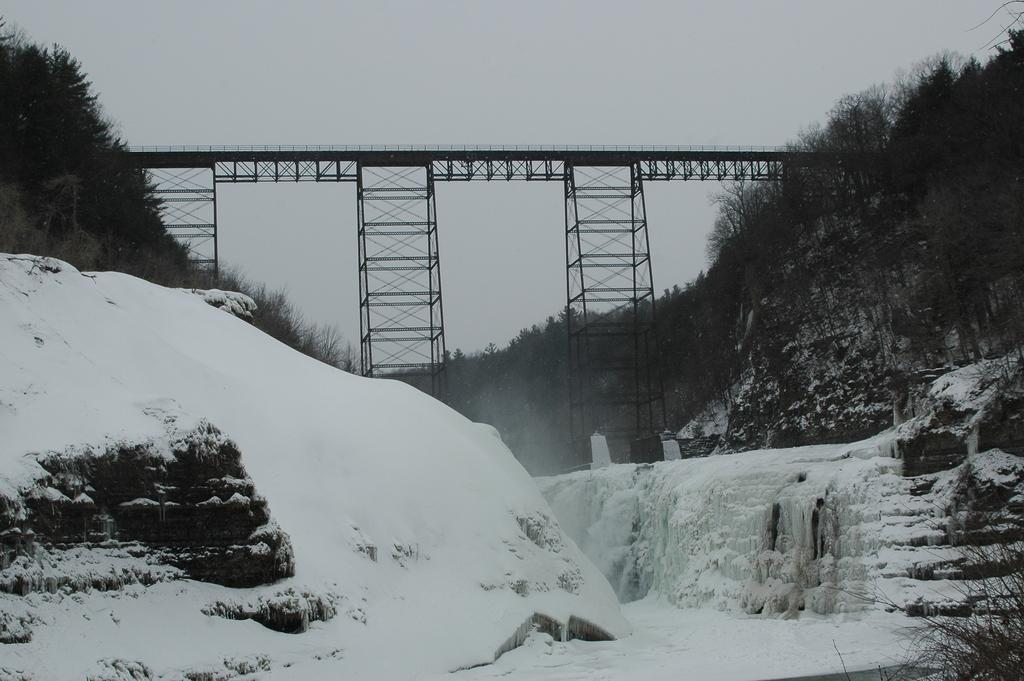What is covering the ground in the image? There is snow on the ground. What type of natural features can be seen in the image? Rocks are visible in the image. What structures can be seen in the background of the image? There is a bridge and poles in the background of the image. What type of vegetation is visible in the background of the image? There are trees in the background of the image. What else can be seen in the background of the image? There are rocks in the background of the image. What part of the natural environment is visible in the background of the image? The sky is visible in the background of the image. What type of juice is being served in the image? There is no juice present in the image; it features snow, rocks, a bridge, poles, trees, and the sky. 